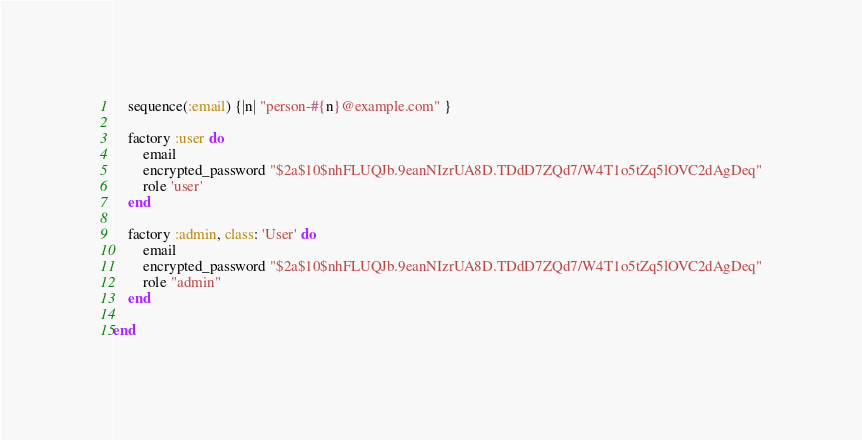<code> <loc_0><loc_0><loc_500><loc_500><_Ruby_>
	sequence(:email) {|n| "person-#{n}@example.com" }

	factory :user do
		email
		encrypted_password "$2a$10$nhFLUQJb.9eanNIzrUA8D.TDdD7ZQd7/W4T1o5tZq5lOVC2dAgDeq"
		role 'user'
	end

	factory :admin, class: 'User' do
		email
		encrypted_password "$2a$10$nhFLUQJb.9eanNIzrUA8D.TDdD7ZQd7/W4T1o5tZq5lOVC2dAgDeq"
		role "admin"
	end

end
</code> 